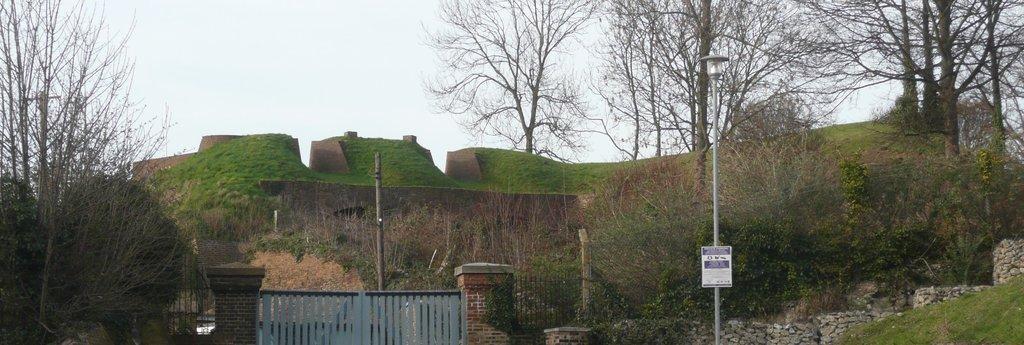Describe this image in one or two sentences. As we can see in the image there is a gate, pole, stones, trees and grass. On the top there is sky. 